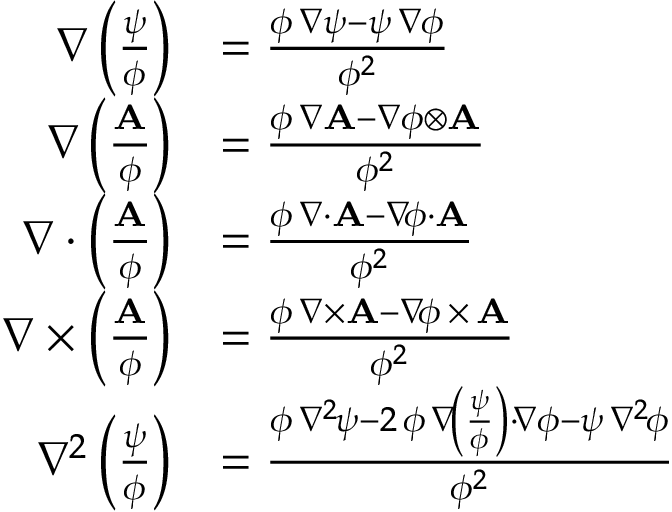<formula> <loc_0><loc_0><loc_500><loc_500>{ \begin{array} { r l } { \nabla \left ( { \frac { \psi } { \phi } } \right ) } & { = { \frac { \phi \, \nabla \psi - \psi \, \nabla \phi } { \phi ^ { 2 } } } } \\ { \nabla \left ( { \frac { A } { \phi } } \right ) } & { = { \frac { \phi \, \nabla A - \nabla \phi \otimes A } { \phi ^ { 2 } } } } \\ { \nabla \cdot \left ( { \frac { A } { \phi } } \right ) } & { = { \frac { \phi \, \nabla { \cdot } A - \nabla \, \phi \cdot A } { \phi ^ { 2 } } } } \\ { \nabla \times \left ( { \frac { A } { \phi } } \right ) } & { = { \frac { \phi \, \nabla { \times } A - \nabla \, \phi \, { \times } \, A } { \phi ^ { 2 } } } } \\ { \nabla ^ { 2 } \left ( { \frac { \psi } { \phi } } \right ) } & { = { \frac { \phi \, \nabla ^ { 2 \, } \psi - 2 \, \phi \, \nabla \, \left ( { \frac { \psi } { \phi } } \right ) \cdot \, \nabla \phi - \psi \, \nabla ^ { 2 \, } \phi } { \phi ^ { 2 } } } } \end{array} }</formula> 